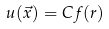<formula> <loc_0><loc_0><loc_500><loc_500>u ( \vec { x } ) = C f ( r )</formula> 